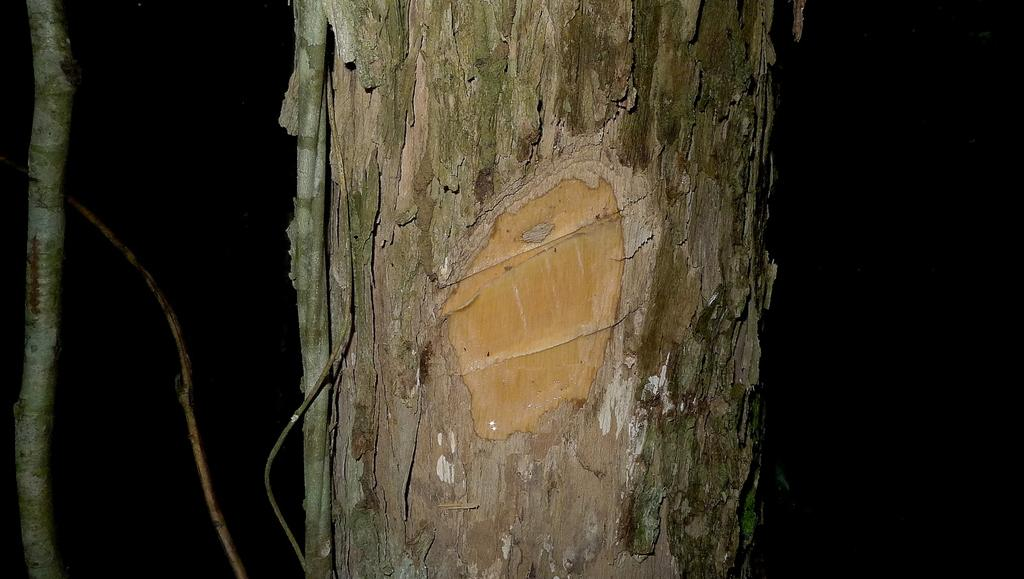What is the main object in the image? There is a branch in the image. Can you describe the colors of the branch? The branch has brown and greenish colors. What can be seen in the background of the image? The background of the image is black. What type of liquid is dripping from the branch in the image? There is no liquid dripping from the branch in the image. Can you see any wings on the branch in the image? There are no wings present on the branch in the image. 